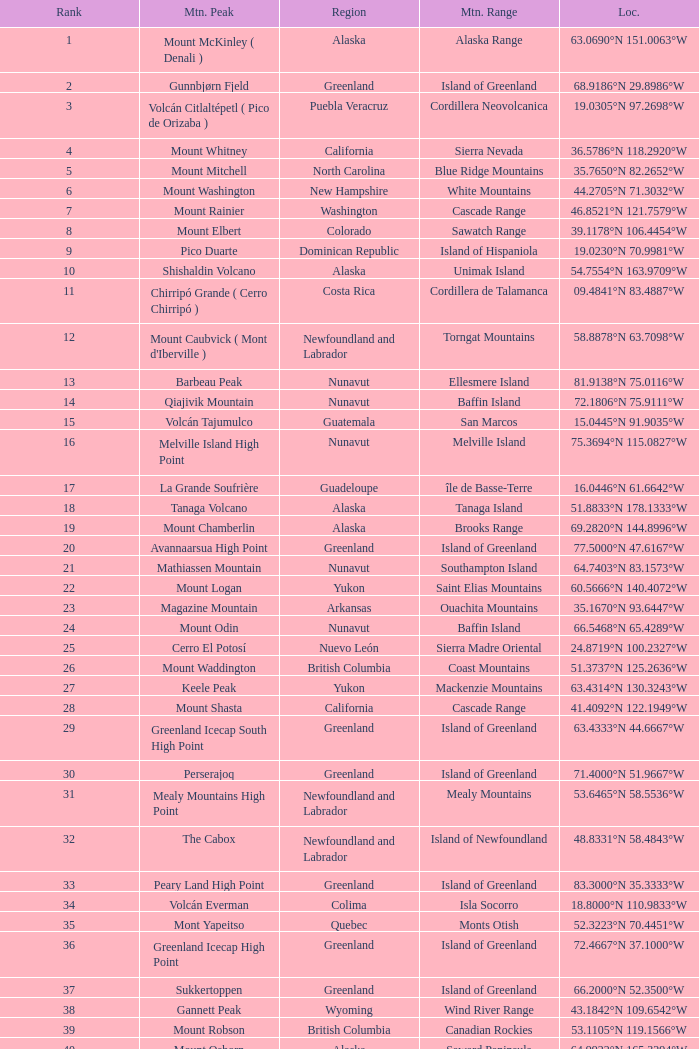Name the Region with a Mountain Peak of dillingham high point? Alaska. 